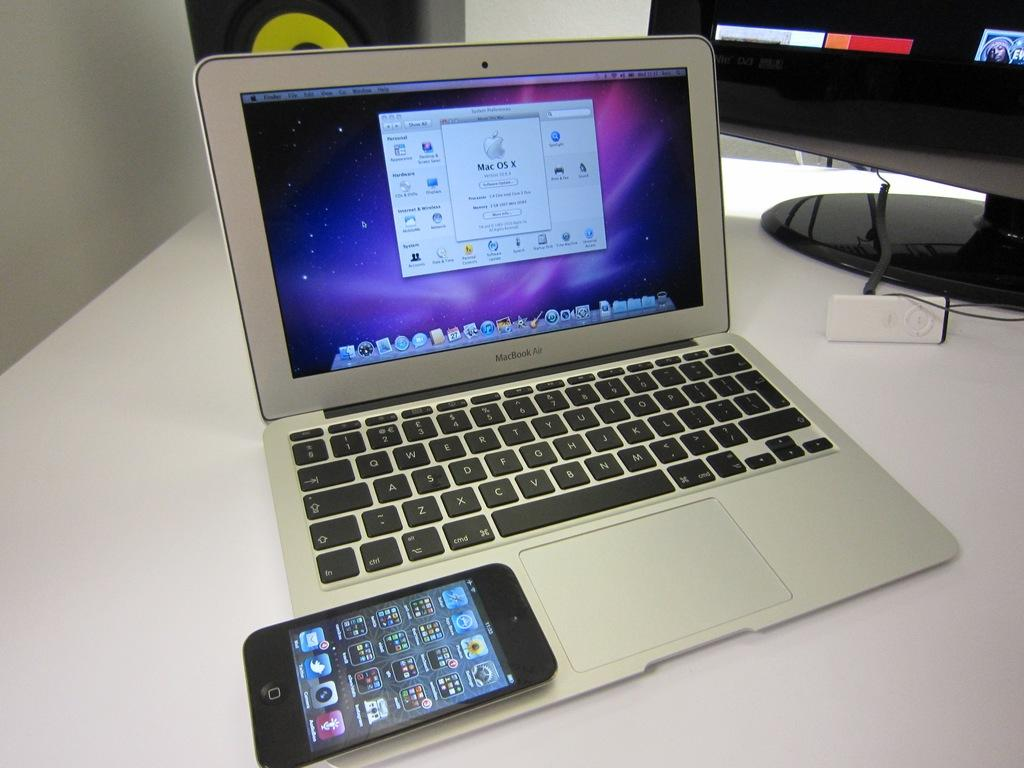<image>
Write a terse but informative summary of the picture. A smart phone rests on an open MacBook Air laptop. 